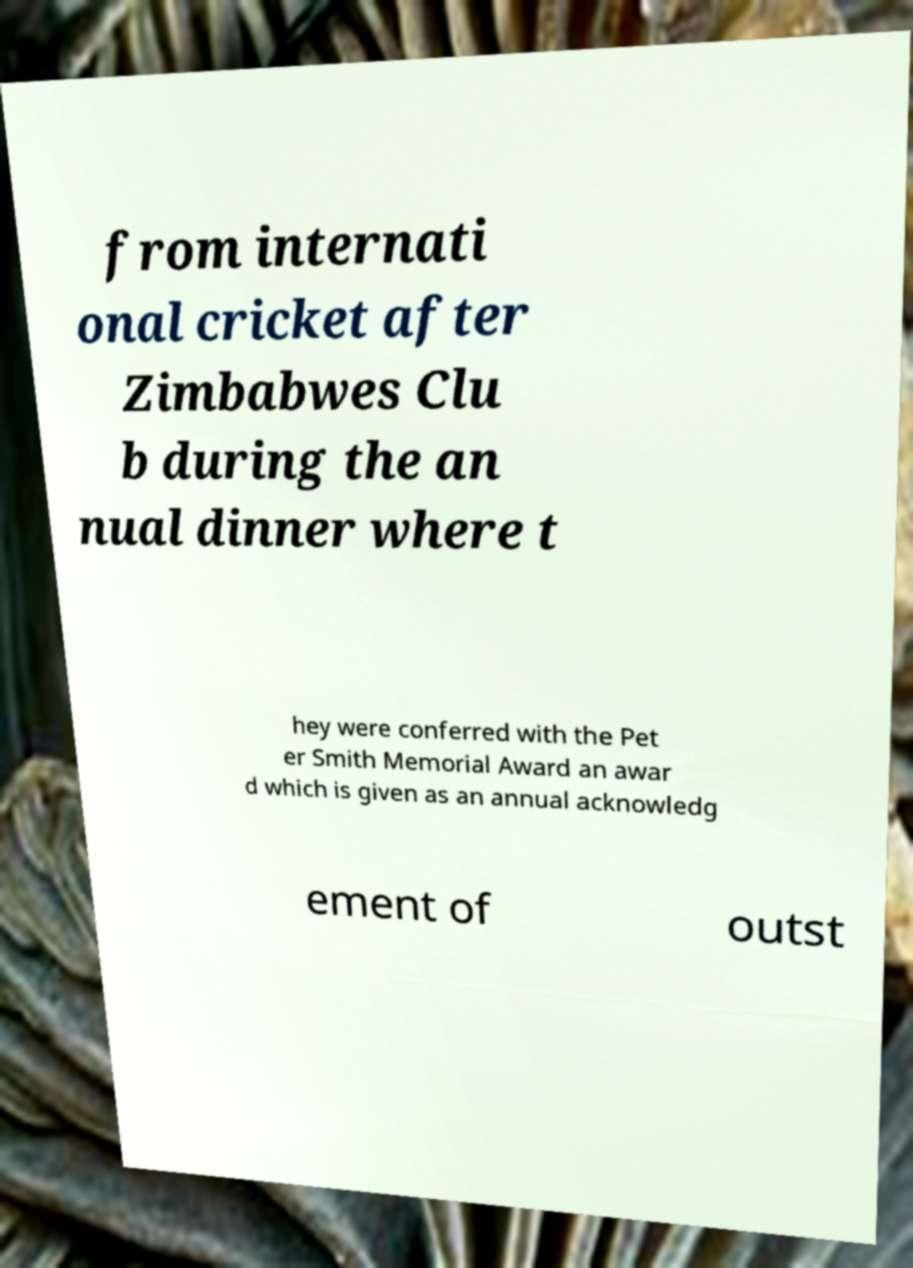For documentation purposes, I need the text within this image transcribed. Could you provide that? from internati onal cricket after Zimbabwes Clu b during the an nual dinner where t hey were conferred with the Pet er Smith Memorial Award an awar d which is given as an annual acknowledg ement of outst 